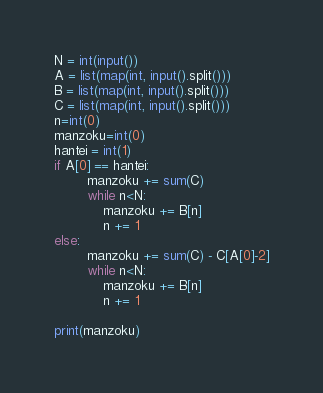<code> <loc_0><loc_0><loc_500><loc_500><_Python_>N = int(input())
A = list(map(int, input().split()))
B = list(map(int, input().split()))
C = list(map(int, input().split()))
n=int(0)
manzoku=int(0)
hantei = int(1)
if A[0] == hantei:
        manzoku += sum(C)
        while n<N:
            manzoku += B[n]
            n += 1
else:
        manzoku += sum(C) - C[A[0]-2]
        while n<N:
            manzoku += B[n]
            n += 1

print(manzoku)
</code> 